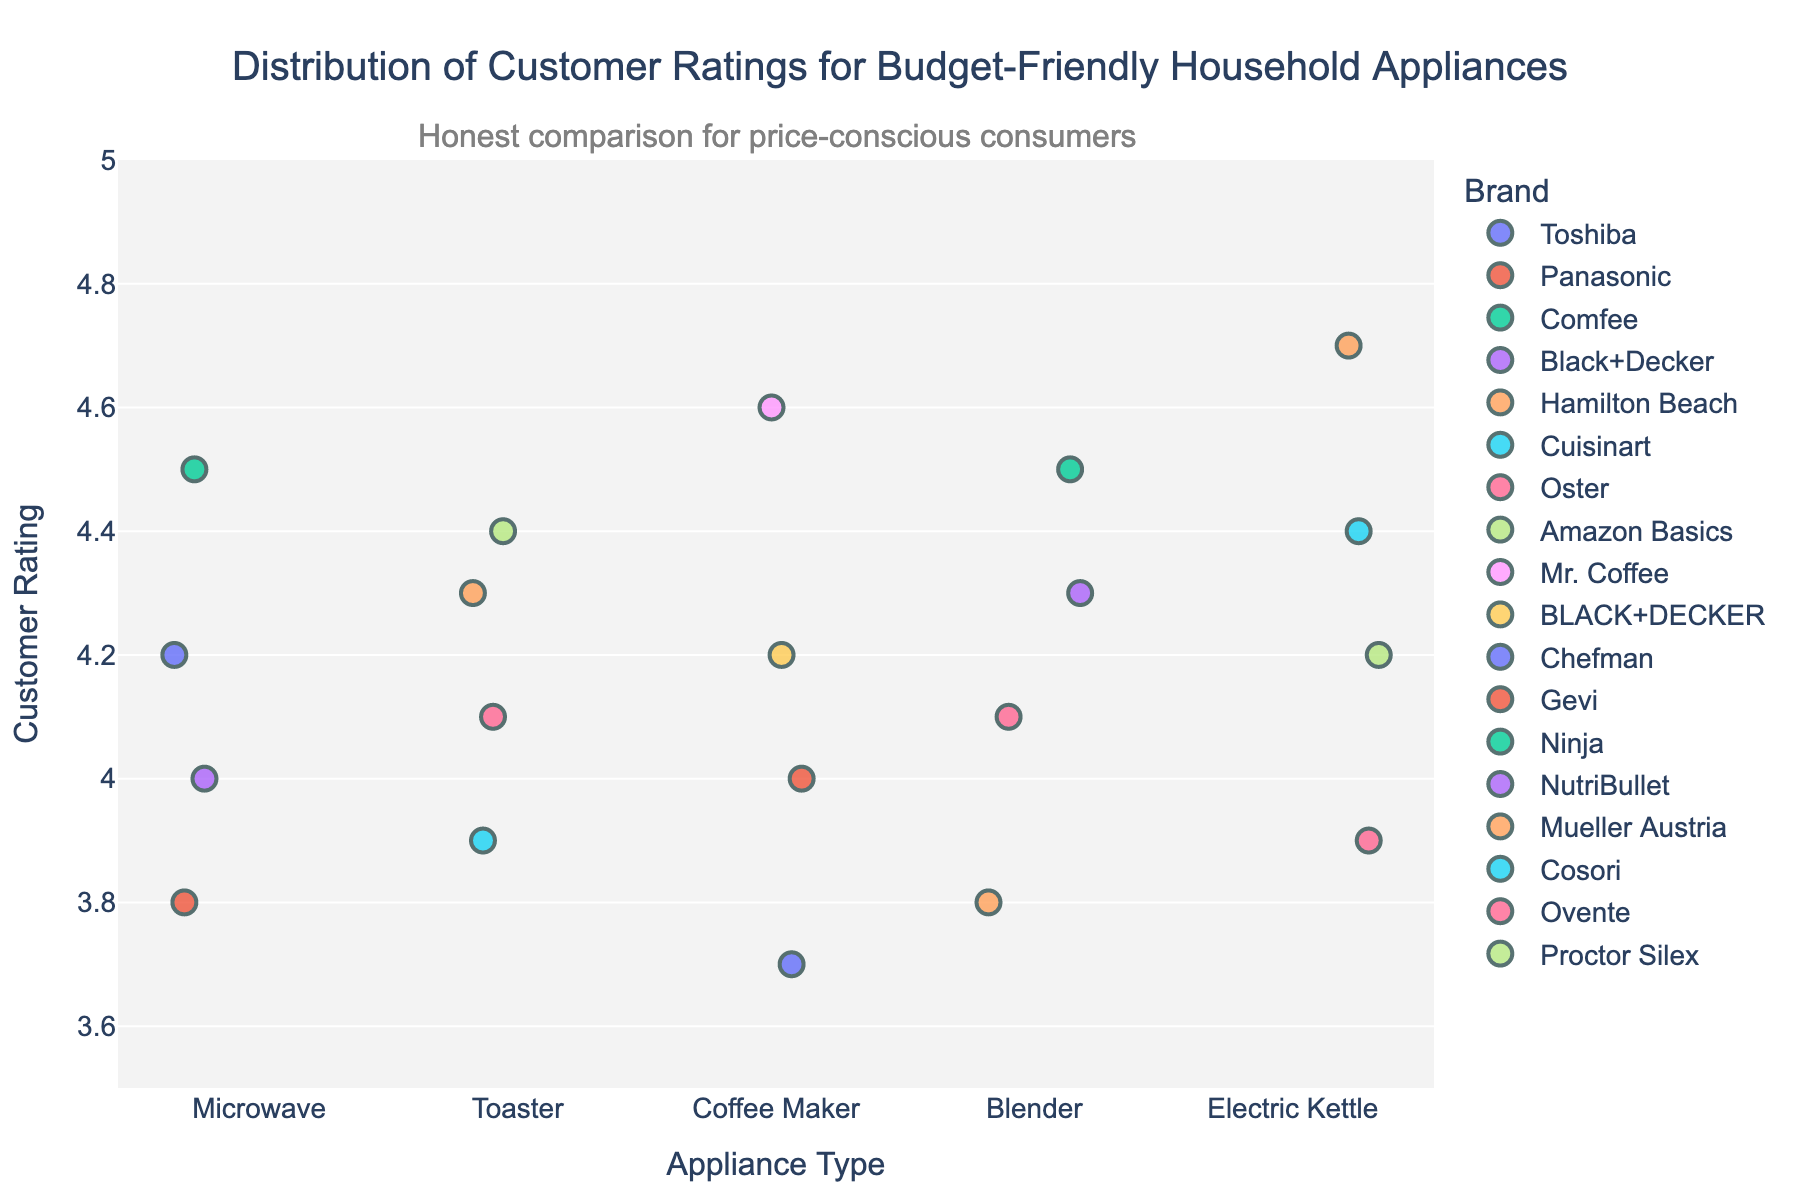What is the title of the plot? The title of the plot is located at the top center and it reads "Distribution of Customer Ratings for Budget-Friendly Household Appliances".
Answer: Distribution of Customer Ratings for Budget-Friendly Household Appliances Which appliance has the highest maximum rating? By looking at the y-axis where the customer ratings are plotted, the Electric Kettle category has the highest maximum rating of 4.7.
Answer: Electric Kettle How many brands are shown in the Toaster category? There are four distinct points in the Toaster category on the x-axis, each representing different brands: Hamilton Beach, Cuisinart, Oster, and Amazon Basics.
Answer: 4 What is the average customer rating for Microwaves? The customer ratings for Microwaves are 4.2, 3.8, 4.5, and 4.0. Adding these gives a total of 16.5, and dividing by 4 results in an average of 4.125.
Answer: 4.125 Which appliance type shows the lowest rating in the plot? By examining the minimum values along the y-axis, the Coffee Maker category shows the lowest rating of 3.7.
Answer: Coffee Maker Compare the highest rating between Blender and Toaster, which one is higher and by how much? The highest rating for Blenders is 4.5, and for Toaster, it is 4.4. The difference between 4.5 and 4.4 is 0.1.
Answer: Blender by 0.1 What do the colors in the plot represent? The legend in the plot indicates that different colors represent different brands.
Answer: Brands Which brand has the highest-rated Coffee Maker? By hovering over or looking at the customer ratings in the Coffee Maker category, the highest rating is 4.6, which corresponds to the Mr. Coffee brand.
Answer: Mr. Coffee How are data points differentiated within each appliance category in the plot? Data points within each appliance category are differentiated by color, which corresponds to different brands according to the legend.
Answer: By color representing different brands What is the overall range of customer ratings represented in the plot? The plot shows customer ratings ranging from the lowest point of 3.7 (Chefman Coffee Maker) to the highest point of 4.7 (Mueller Austria Electric Kettle).
Answer: 3.7 to 4.7 